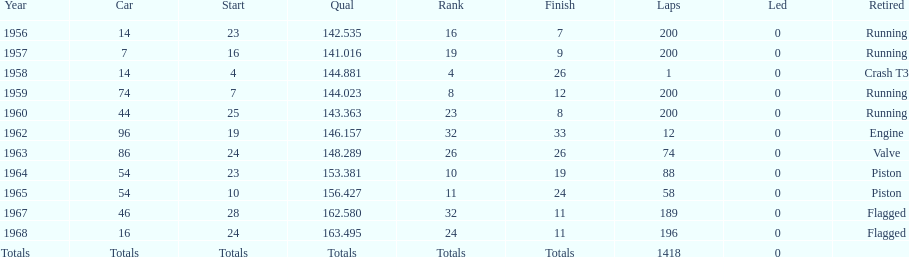Could you help me parse every detail presented in this table? {'header': ['Year', 'Car', 'Start', 'Qual', 'Rank', 'Finish', 'Laps', 'Led', 'Retired'], 'rows': [['1956', '14', '23', '142.535', '16', '7', '200', '0', 'Running'], ['1957', '7', '16', '141.016', '19', '9', '200', '0', 'Running'], ['1958', '14', '4', '144.881', '4', '26', '1', '0', 'Crash T3'], ['1959', '74', '7', '144.023', '8', '12', '200', '0', 'Running'], ['1960', '44', '25', '143.363', '23', '8', '200', '0', 'Running'], ['1962', '96', '19', '146.157', '32', '33', '12', '0', 'Engine'], ['1963', '86', '24', '148.289', '26', '26', '74', '0', 'Valve'], ['1964', '54', '23', '153.381', '10', '19', '88', '0', 'Piston'], ['1965', '54', '10', '156.427', '11', '24', '58', '0', 'Piston'], ['1967', '46', '28', '162.580', '32', '11', '189', '0', 'Flagged'], ['1968', '16', '24', '163.495', '24', '11', '196', '0', 'Flagged'], ['Totals', 'Totals', 'Totals', 'Totals', 'Totals', 'Totals', '1418', '0', '']]} Tell me the number of times he finished above 10th place. 3. 